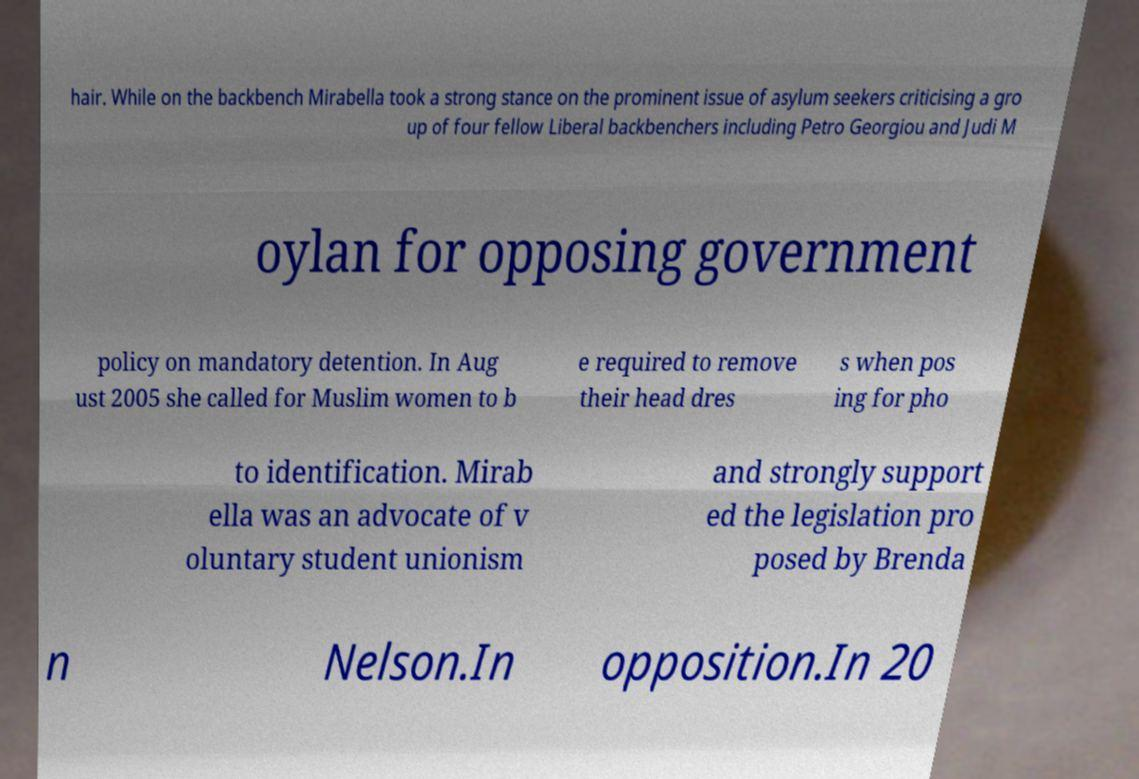Can you read and provide the text displayed in the image?This photo seems to have some interesting text. Can you extract and type it out for me? hair. While on the backbench Mirabella took a strong stance on the prominent issue of asylum seekers criticising a gro up of four fellow Liberal backbenchers including Petro Georgiou and Judi M oylan for opposing government policy on mandatory detention. In Aug ust 2005 she called for Muslim women to b e required to remove their head dres s when pos ing for pho to identification. Mirab ella was an advocate of v oluntary student unionism and strongly support ed the legislation pro posed by Brenda n Nelson.In opposition.In 20 